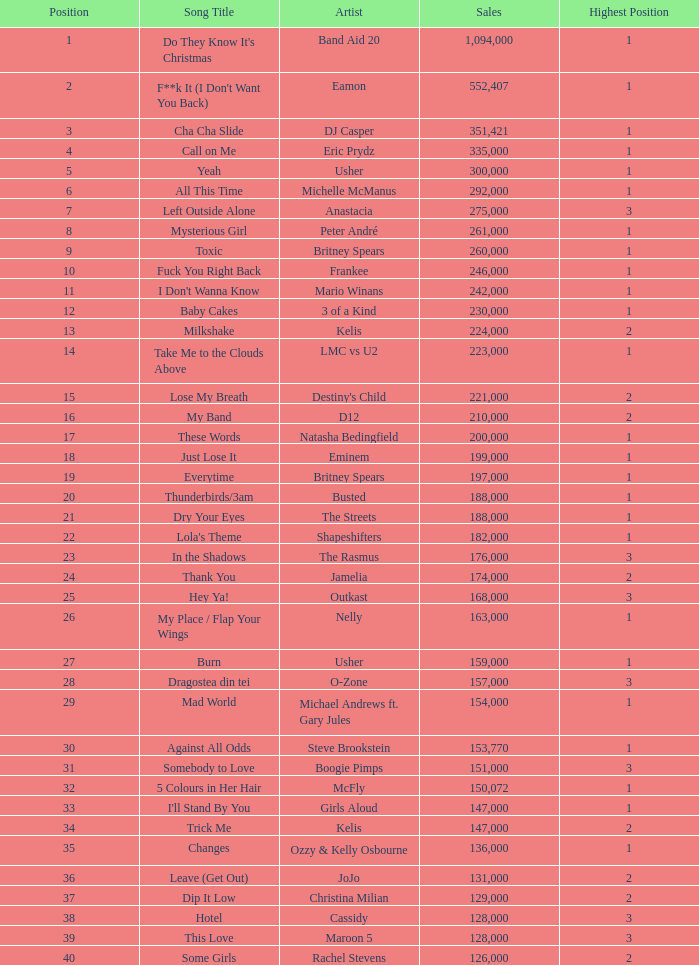What were the earnings for dj casper when he held a spot lower than 13? 351421.0. 